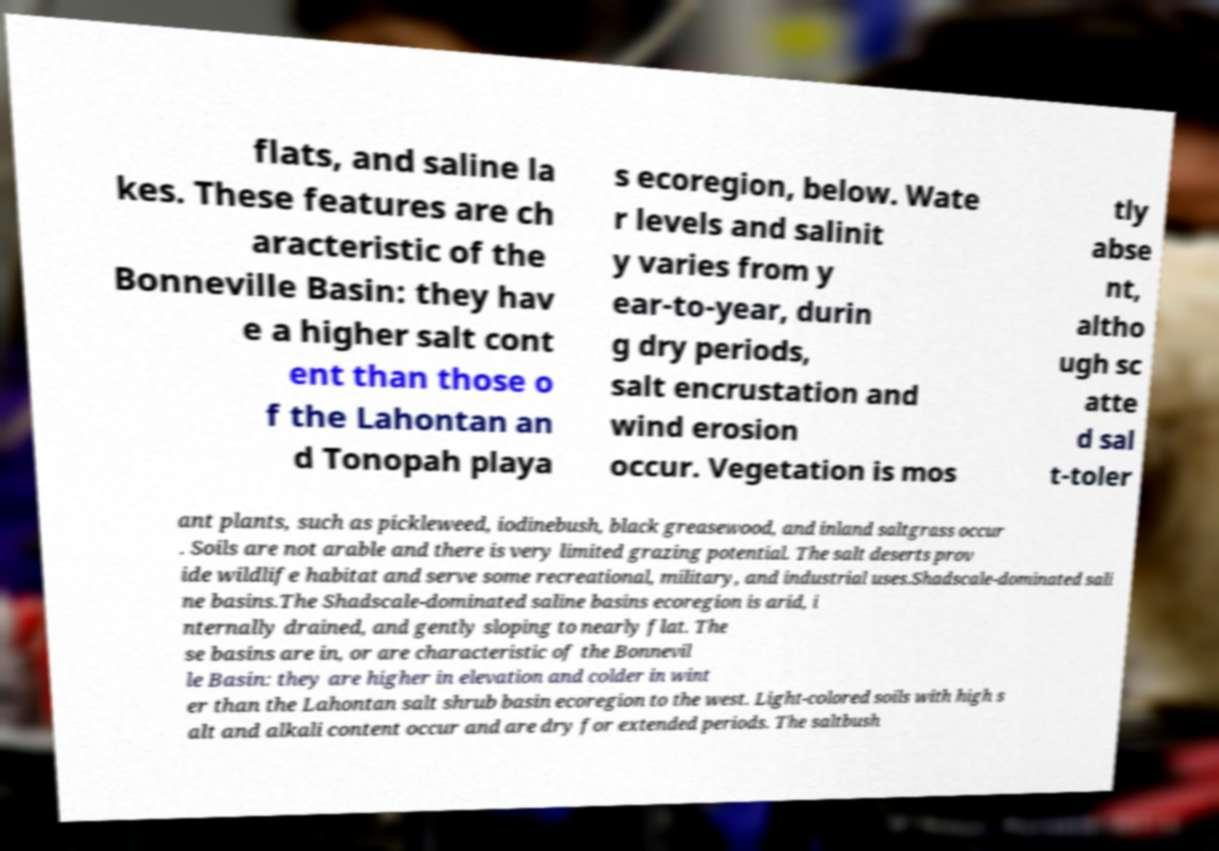Can you accurately transcribe the text from the provided image for me? flats, and saline la kes. These features are ch aracteristic of the Bonneville Basin: they hav e a higher salt cont ent than those o f the Lahontan an d Tonopah playa s ecoregion, below. Wate r levels and salinit y varies from y ear-to-year, durin g dry periods, salt encrustation and wind erosion occur. Vegetation is mos tly abse nt, altho ugh sc atte d sal t-toler ant plants, such as pickleweed, iodinebush, black greasewood, and inland saltgrass occur . Soils are not arable and there is very limited grazing potential. The salt deserts prov ide wildlife habitat and serve some recreational, military, and industrial uses.Shadscale-dominated sali ne basins.The Shadscale-dominated saline basins ecoregion is arid, i nternally drained, and gently sloping to nearly flat. The se basins are in, or are characteristic of the Bonnevil le Basin: they are higher in elevation and colder in wint er than the Lahontan salt shrub basin ecoregion to the west. Light-colored soils with high s alt and alkali content occur and are dry for extended periods. The saltbush 